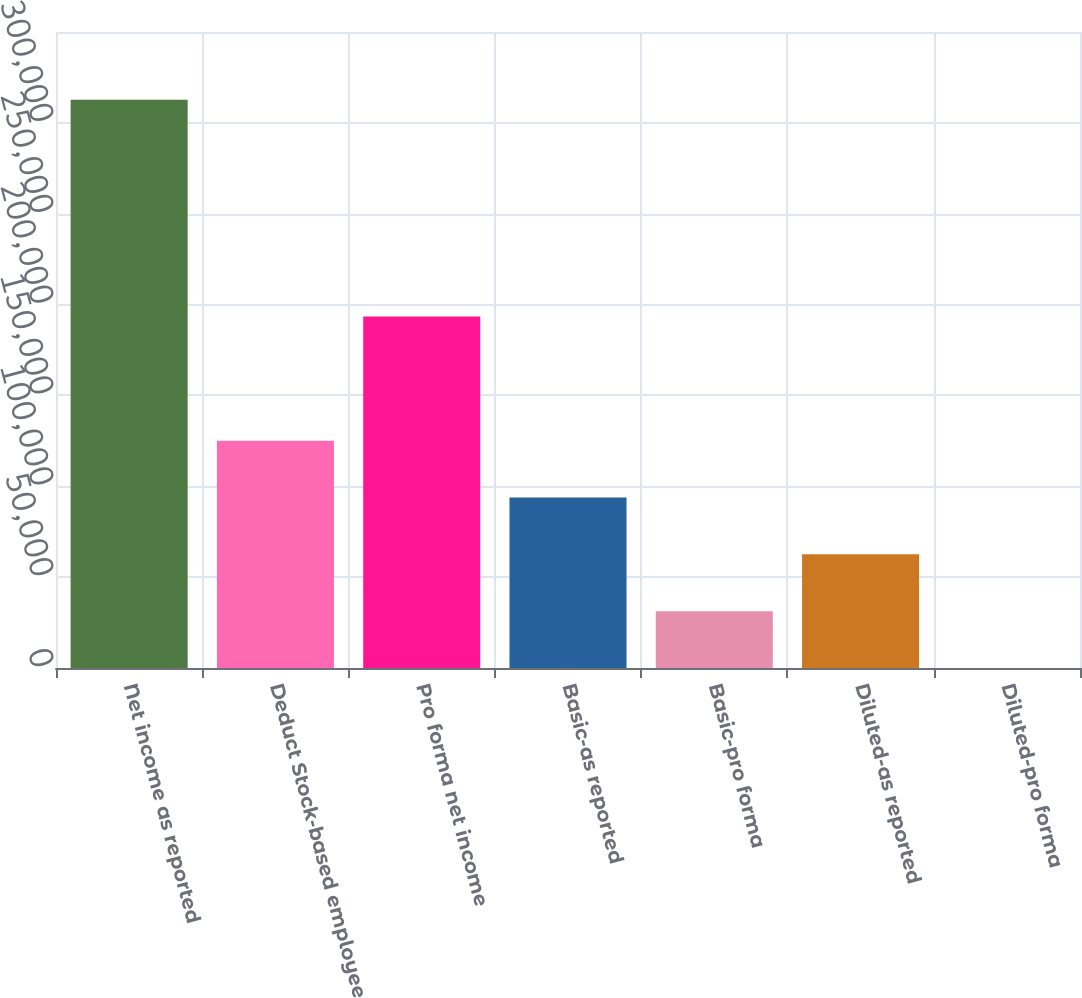<chart> <loc_0><loc_0><loc_500><loc_500><bar_chart><fcel>Net income as reported<fcel>Deduct Stock-based employee<fcel>Pro forma net income<fcel>Basic-as reported<fcel>Basic-pro forma<fcel>Diluted-as reported<fcel>Diluted-pro forma<nl><fcel>312723<fcel>125090<fcel>193486<fcel>93817.3<fcel>31272.8<fcel>62545<fcel>0.54<nl></chart> 